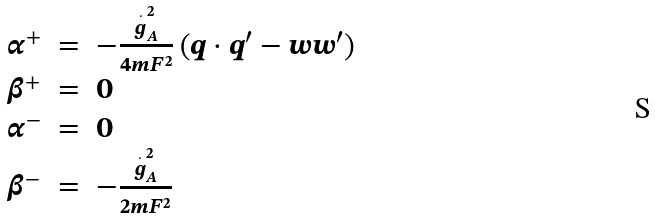Convert formula to latex. <formula><loc_0><loc_0><loc_500><loc_500>\begin{array} [ t ] { c c l } \alpha ^ { + } & = & - \frac { \stackrel { . } { g } _ { A } ^ { 2 } } { 4 m F ^ { 2 } } \left ( q \cdot q ^ { \prime } - w w ^ { \prime } \right ) \\ \beta ^ { + } & = & 0 \\ \alpha ^ { - } & = & 0 \\ \beta ^ { - } & = & - \frac { \stackrel { . } { g } _ { A } ^ { 2 } } { 2 m F ^ { 2 } } \end{array}</formula> 